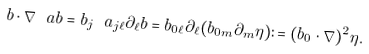Convert formula to latex. <formula><loc_0><loc_0><loc_500><loc_500>b \cdot \nabla _ { \ } a b = b _ { j } \ a _ { j \ell } \partial _ { \ell } b = b _ { 0 \ell } \partial _ { \ell } ( b _ { 0 m } \partial _ { m } \eta ) \colon = ( b _ { 0 } \cdot \nabla ) ^ { 2 } \eta .</formula> 